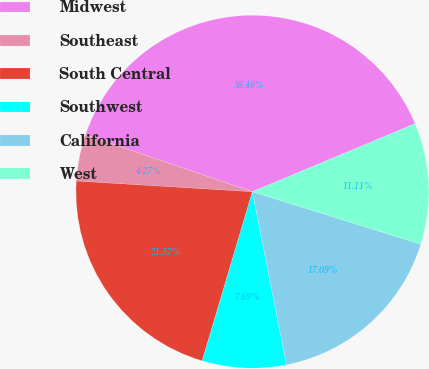Convert chart. <chart><loc_0><loc_0><loc_500><loc_500><pie_chart><fcel>Midwest<fcel>Southeast<fcel>South Central<fcel>Southwest<fcel>California<fcel>West<nl><fcel>38.46%<fcel>4.27%<fcel>21.37%<fcel>7.69%<fcel>17.09%<fcel>11.11%<nl></chart> 